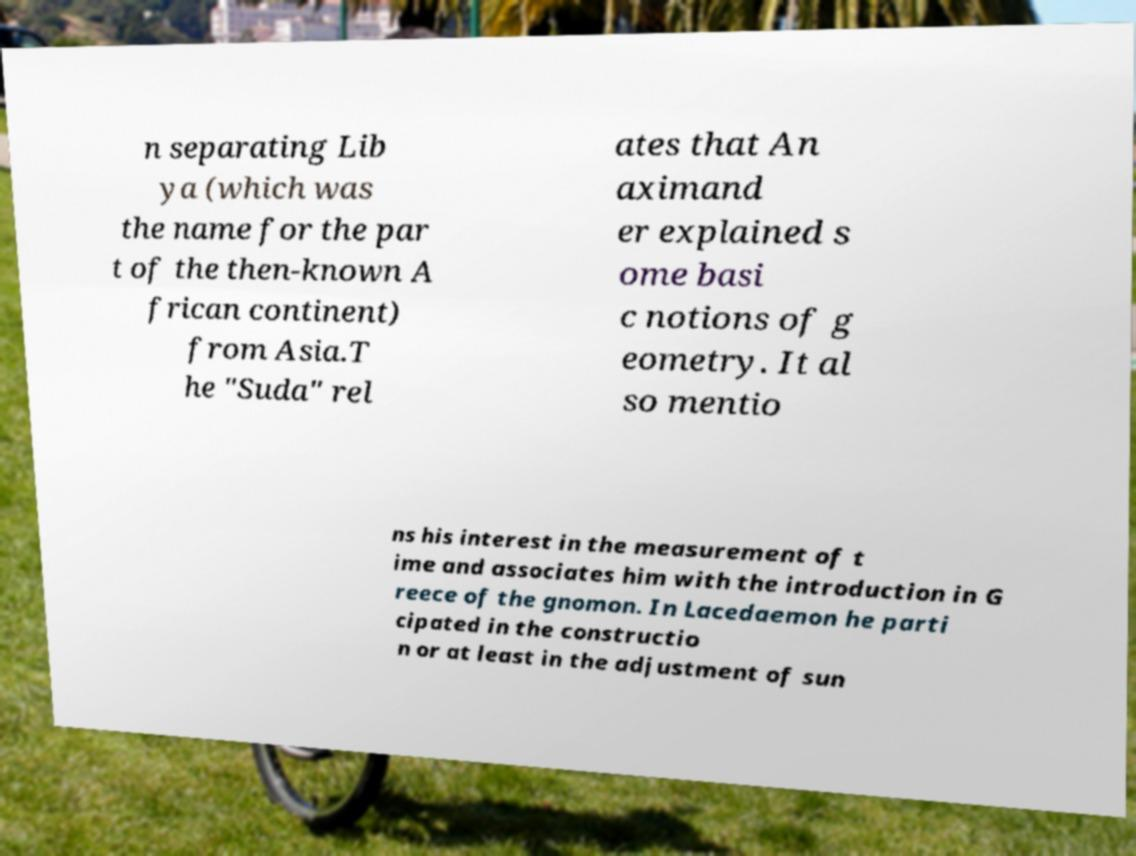What messages or text are displayed in this image? I need them in a readable, typed format. n separating Lib ya (which was the name for the par t of the then-known A frican continent) from Asia.T he "Suda" rel ates that An aximand er explained s ome basi c notions of g eometry. It al so mentio ns his interest in the measurement of t ime and associates him with the introduction in G reece of the gnomon. In Lacedaemon he parti cipated in the constructio n or at least in the adjustment of sun 